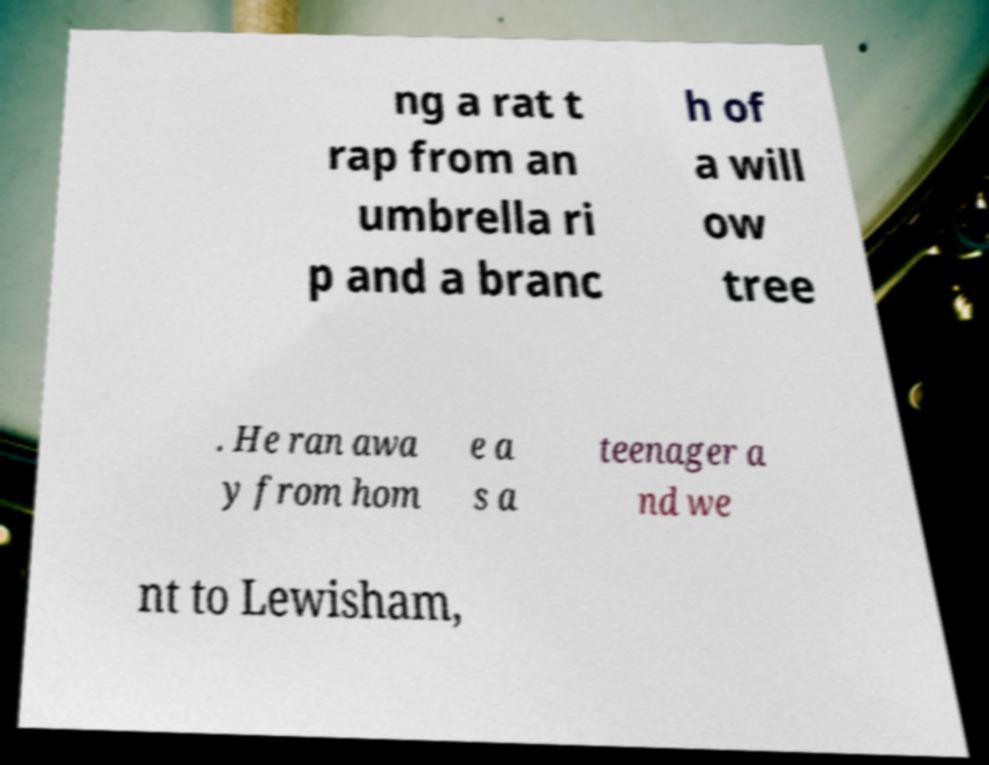Please identify and transcribe the text found in this image. ng a rat t rap from an umbrella ri p and a branc h of a will ow tree . He ran awa y from hom e a s a teenager a nd we nt to Lewisham, 